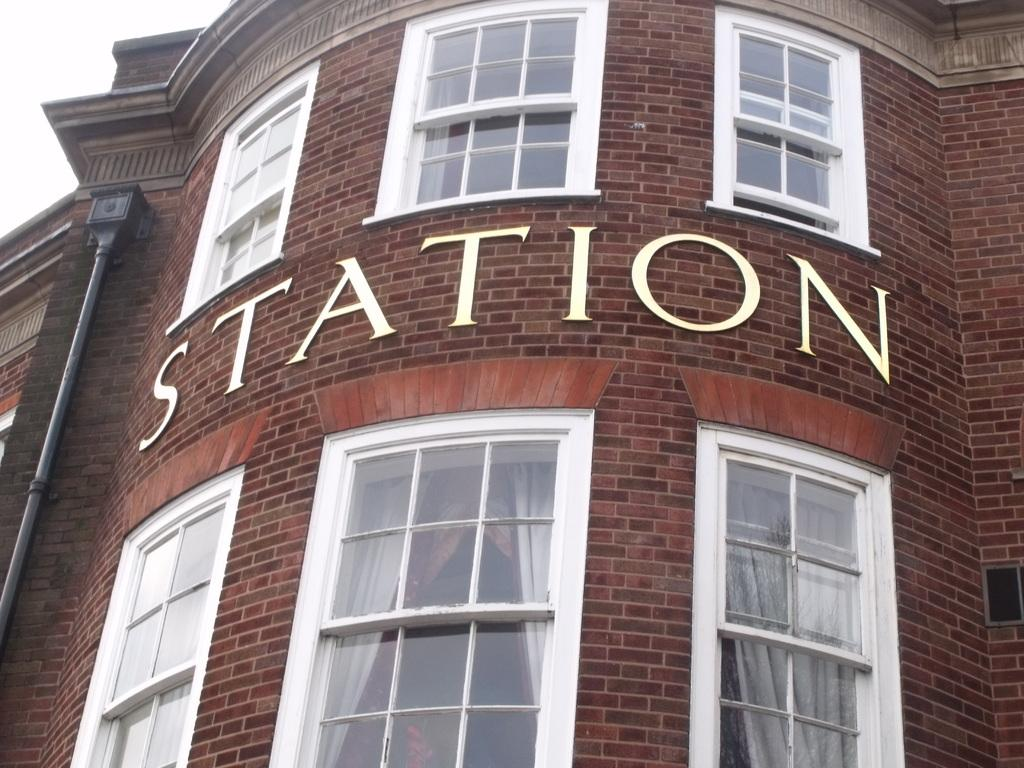What type of structure is in the image? There is a building in the image. What feature can be seen on the building? There are windows on the building. What is visible through the windows? Curtains are visible through the glass of the windows. What is written on the brick wall of the building? The letters spell out "STATION". What type of powder is being used in the image? There is no powder present in the image. 